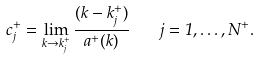<formula> <loc_0><loc_0><loc_500><loc_500>c _ { j } ^ { + } = \lim _ { k \rightarrow k _ { j } ^ { + } } \frac { ( k - k _ { j } ^ { + } ) } { a ^ { + } ( k ) } \quad j = 1 , \dots , N ^ { + } .</formula> 